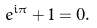<formula> <loc_0><loc_0><loc_500><loc_500>e ^ { i \pi } + 1 = 0 .</formula> 